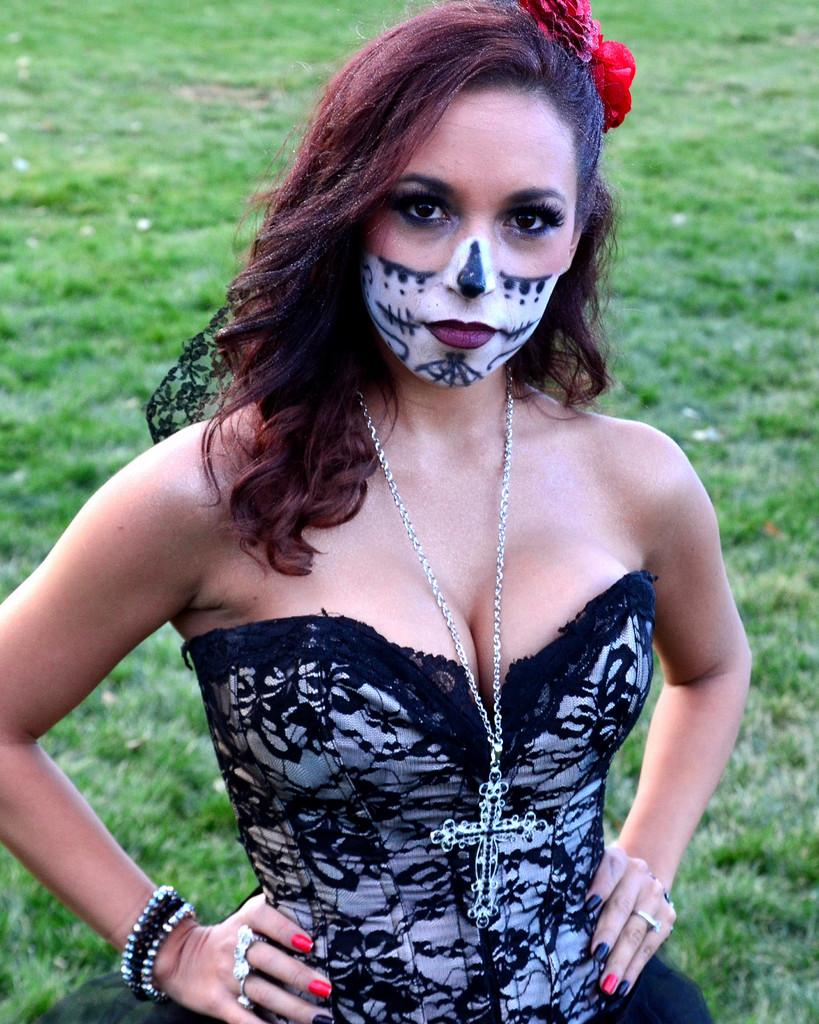What is present in the image? There is a woman in the image. What is unique about the woman's appearance? The woman has a painting on her. What is the woman's position in the image? The woman is standing on the ground. What type of house is depicted in the painting on the woman? There is no house depicted in the painting on the woman, as the facts provided do not mention any house or painting details. How many beads are present in the painting on the woman? There is no information about beads in the painting on the woman, as the facts provided do not mention any beads. 